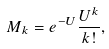<formula> <loc_0><loc_0><loc_500><loc_500>M _ { k } = e ^ { - U } \frac { U ^ { k } } { k ! } ,</formula> 